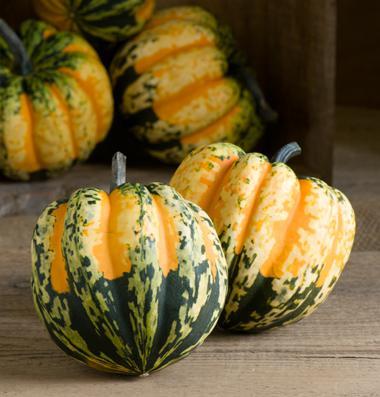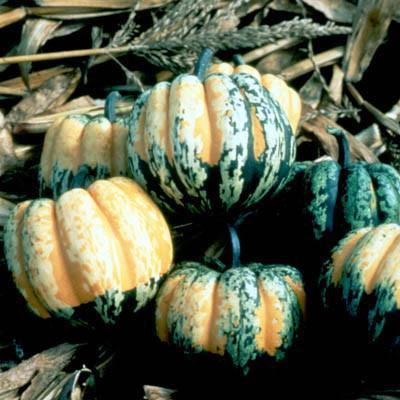The first image is the image on the left, the second image is the image on the right. Given the left and right images, does the statement "The left image includes multiple squash with yellow tops and green variegated bottoms and does not include any solid colored squash." hold true? Answer yes or no. Yes. 